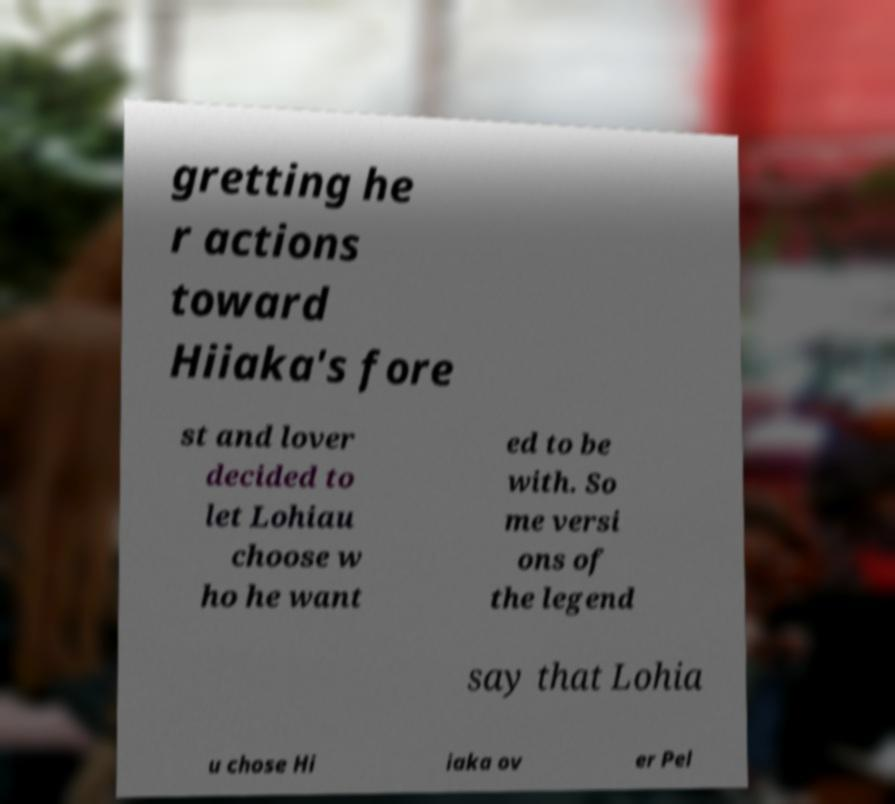Could you assist in decoding the text presented in this image and type it out clearly? gretting he r actions toward Hiiaka's fore st and lover decided to let Lohiau choose w ho he want ed to be with. So me versi ons of the legend say that Lohia u chose Hi iaka ov er Pel 